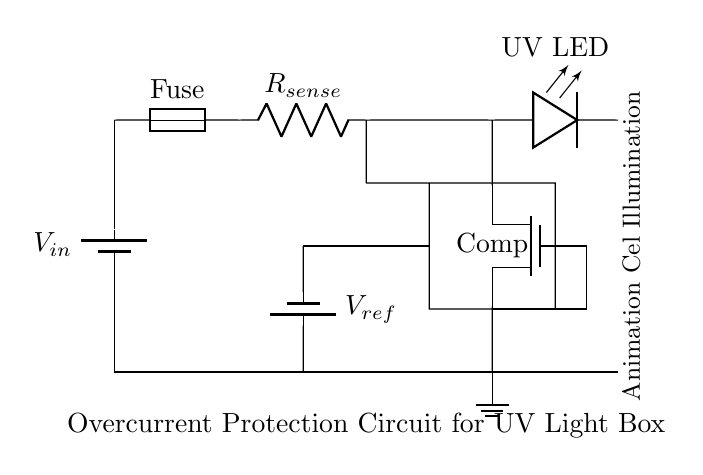What is the function of the fuse in this circuit? The fuse serves as a protective component that disconnects the circuit in case of overcurrent, preventing damage to the rest of the circuit.
Answer: Protection against overcurrent What is the role of the current sense resistor? The current sense resistor allows for the measurement of current flowing through the circuit, which is critical for determining if the current exceeds a safe level.
Answer: Current measurement How many main components are in this circuit? The circuit contains four main components: a fuse, a current sense resistor, a MOSFET, and a comparator.
Answer: Four What does the comparator do in this circuit? The comparator compares the voltage across the current sense resistor to a reference voltage and controls the MOSFET based on whether the current exceeds a predetermined threshold.
Answer: Controls the MOSFET What happens when the current exceeds the reference voltage? When the current exceeds the reference voltage, the comparator output turns off the MOSFET, cutting off power to the UV LED to prevent damage.
Answer: MOSFET turns off What type of protection does this circuit provide? This circuit provides overcurrent protection specifically designed to prevent excessive current from damaging the UV light used in animation cel creation.
Answer: Overcurrent protection 